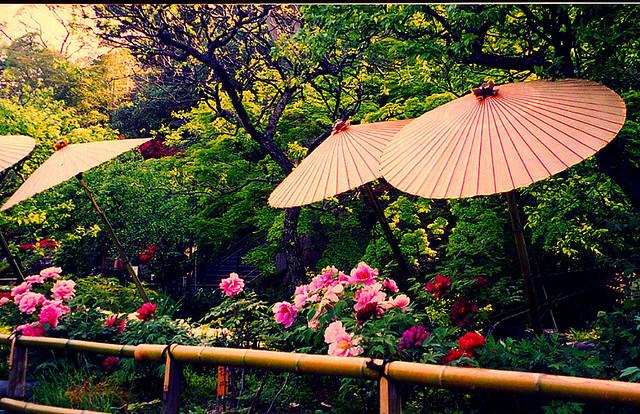What color are the umbrellas?
Write a very short answer. Pink. What season is present?
Be succinct. Spring. Where are the flowers?
Keep it brief. Behind fence. 